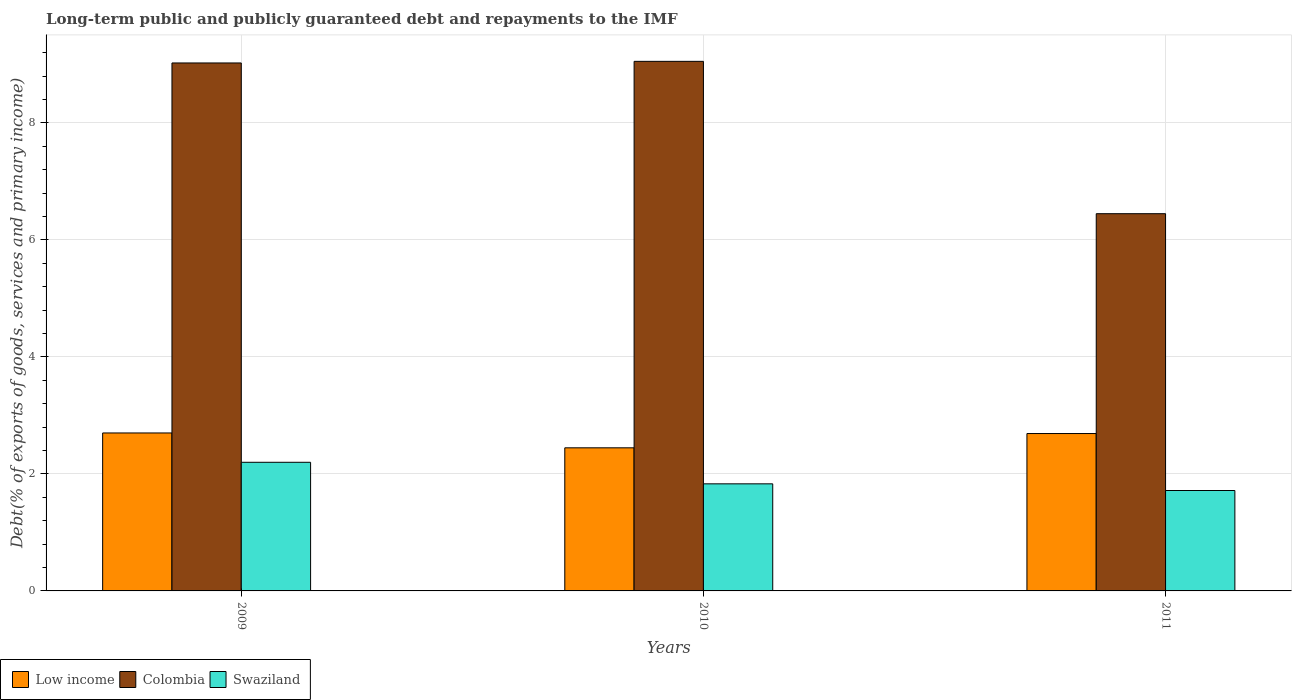How many different coloured bars are there?
Keep it short and to the point. 3. Are the number of bars per tick equal to the number of legend labels?
Keep it short and to the point. Yes. How many bars are there on the 2nd tick from the right?
Provide a succinct answer. 3. What is the debt and repayments in Low income in 2010?
Offer a very short reply. 2.45. Across all years, what is the maximum debt and repayments in Swaziland?
Your response must be concise. 2.2. Across all years, what is the minimum debt and repayments in Low income?
Ensure brevity in your answer.  2.45. In which year was the debt and repayments in Low income maximum?
Provide a short and direct response. 2009. In which year was the debt and repayments in Colombia minimum?
Provide a succinct answer. 2011. What is the total debt and repayments in Low income in the graph?
Keep it short and to the point. 7.84. What is the difference between the debt and repayments in Swaziland in 2009 and that in 2010?
Give a very brief answer. 0.37. What is the difference between the debt and repayments in Low income in 2010 and the debt and repayments in Swaziland in 2009?
Make the answer very short. 0.25. What is the average debt and repayments in Low income per year?
Make the answer very short. 2.61. In the year 2011, what is the difference between the debt and repayments in Swaziland and debt and repayments in Low income?
Your answer should be compact. -0.97. In how many years, is the debt and repayments in Swaziland greater than 3.6 %?
Provide a succinct answer. 0. What is the ratio of the debt and repayments in Swaziland in 2010 to that in 2011?
Your answer should be compact. 1.07. Is the debt and repayments in Colombia in 2010 less than that in 2011?
Your answer should be compact. No. Is the difference between the debt and repayments in Swaziland in 2009 and 2010 greater than the difference between the debt and repayments in Low income in 2009 and 2010?
Your answer should be very brief. Yes. What is the difference between the highest and the second highest debt and repayments in Swaziland?
Offer a very short reply. 0.37. What is the difference between the highest and the lowest debt and repayments in Colombia?
Your response must be concise. 2.6. In how many years, is the debt and repayments in Swaziland greater than the average debt and repayments in Swaziland taken over all years?
Your answer should be compact. 1. What does the 3rd bar from the left in 2009 represents?
Your answer should be very brief. Swaziland. What does the 1st bar from the right in 2011 represents?
Ensure brevity in your answer.  Swaziland. How many bars are there?
Ensure brevity in your answer.  9. Are all the bars in the graph horizontal?
Your answer should be compact. No. Does the graph contain any zero values?
Give a very brief answer. No. Where does the legend appear in the graph?
Make the answer very short. Bottom left. How many legend labels are there?
Provide a succinct answer. 3. How are the legend labels stacked?
Provide a short and direct response. Horizontal. What is the title of the graph?
Offer a terse response. Long-term public and publicly guaranteed debt and repayments to the IMF. What is the label or title of the X-axis?
Give a very brief answer. Years. What is the label or title of the Y-axis?
Give a very brief answer. Debt(% of exports of goods, services and primary income). What is the Debt(% of exports of goods, services and primary income) of Low income in 2009?
Provide a succinct answer. 2.7. What is the Debt(% of exports of goods, services and primary income) of Colombia in 2009?
Your answer should be very brief. 9.02. What is the Debt(% of exports of goods, services and primary income) of Swaziland in 2009?
Your answer should be compact. 2.2. What is the Debt(% of exports of goods, services and primary income) of Low income in 2010?
Your response must be concise. 2.45. What is the Debt(% of exports of goods, services and primary income) of Colombia in 2010?
Provide a short and direct response. 9.05. What is the Debt(% of exports of goods, services and primary income) in Swaziland in 2010?
Ensure brevity in your answer.  1.83. What is the Debt(% of exports of goods, services and primary income) of Low income in 2011?
Provide a succinct answer. 2.69. What is the Debt(% of exports of goods, services and primary income) of Colombia in 2011?
Your response must be concise. 6.45. What is the Debt(% of exports of goods, services and primary income) in Swaziland in 2011?
Offer a terse response. 1.72. Across all years, what is the maximum Debt(% of exports of goods, services and primary income) in Low income?
Give a very brief answer. 2.7. Across all years, what is the maximum Debt(% of exports of goods, services and primary income) of Colombia?
Provide a short and direct response. 9.05. Across all years, what is the maximum Debt(% of exports of goods, services and primary income) in Swaziland?
Offer a very short reply. 2.2. Across all years, what is the minimum Debt(% of exports of goods, services and primary income) in Low income?
Provide a short and direct response. 2.45. Across all years, what is the minimum Debt(% of exports of goods, services and primary income) of Colombia?
Offer a very short reply. 6.45. Across all years, what is the minimum Debt(% of exports of goods, services and primary income) in Swaziland?
Your answer should be very brief. 1.72. What is the total Debt(% of exports of goods, services and primary income) in Low income in the graph?
Provide a succinct answer. 7.84. What is the total Debt(% of exports of goods, services and primary income) of Colombia in the graph?
Ensure brevity in your answer.  24.53. What is the total Debt(% of exports of goods, services and primary income) in Swaziland in the graph?
Keep it short and to the point. 5.75. What is the difference between the Debt(% of exports of goods, services and primary income) in Low income in 2009 and that in 2010?
Your answer should be compact. 0.25. What is the difference between the Debt(% of exports of goods, services and primary income) in Colombia in 2009 and that in 2010?
Ensure brevity in your answer.  -0.03. What is the difference between the Debt(% of exports of goods, services and primary income) of Swaziland in 2009 and that in 2010?
Offer a very short reply. 0.37. What is the difference between the Debt(% of exports of goods, services and primary income) in Low income in 2009 and that in 2011?
Provide a short and direct response. 0.01. What is the difference between the Debt(% of exports of goods, services and primary income) in Colombia in 2009 and that in 2011?
Provide a short and direct response. 2.58. What is the difference between the Debt(% of exports of goods, services and primary income) in Swaziland in 2009 and that in 2011?
Keep it short and to the point. 0.48. What is the difference between the Debt(% of exports of goods, services and primary income) of Low income in 2010 and that in 2011?
Give a very brief answer. -0.24. What is the difference between the Debt(% of exports of goods, services and primary income) in Colombia in 2010 and that in 2011?
Your answer should be compact. 2.6. What is the difference between the Debt(% of exports of goods, services and primary income) in Swaziland in 2010 and that in 2011?
Make the answer very short. 0.11. What is the difference between the Debt(% of exports of goods, services and primary income) of Low income in 2009 and the Debt(% of exports of goods, services and primary income) of Colombia in 2010?
Make the answer very short. -6.35. What is the difference between the Debt(% of exports of goods, services and primary income) in Low income in 2009 and the Debt(% of exports of goods, services and primary income) in Swaziland in 2010?
Provide a succinct answer. 0.87. What is the difference between the Debt(% of exports of goods, services and primary income) in Colombia in 2009 and the Debt(% of exports of goods, services and primary income) in Swaziland in 2010?
Provide a short and direct response. 7.19. What is the difference between the Debt(% of exports of goods, services and primary income) of Low income in 2009 and the Debt(% of exports of goods, services and primary income) of Colombia in 2011?
Give a very brief answer. -3.75. What is the difference between the Debt(% of exports of goods, services and primary income) in Low income in 2009 and the Debt(% of exports of goods, services and primary income) in Swaziland in 2011?
Give a very brief answer. 0.98. What is the difference between the Debt(% of exports of goods, services and primary income) in Colombia in 2009 and the Debt(% of exports of goods, services and primary income) in Swaziland in 2011?
Offer a terse response. 7.31. What is the difference between the Debt(% of exports of goods, services and primary income) of Low income in 2010 and the Debt(% of exports of goods, services and primary income) of Colombia in 2011?
Your response must be concise. -4. What is the difference between the Debt(% of exports of goods, services and primary income) in Low income in 2010 and the Debt(% of exports of goods, services and primary income) in Swaziland in 2011?
Ensure brevity in your answer.  0.73. What is the difference between the Debt(% of exports of goods, services and primary income) in Colombia in 2010 and the Debt(% of exports of goods, services and primary income) in Swaziland in 2011?
Your response must be concise. 7.34. What is the average Debt(% of exports of goods, services and primary income) in Low income per year?
Keep it short and to the point. 2.61. What is the average Debt(% of exports of goods, services and primary income) in Colombia per year?
Keep it short and to the point. 8.18. What is the average Debt(% of exports of goods, services and primary income) in Swaziland per year?
Your answer should be compact. 1.92. In the year 2009, what is the difference between the Debt(% of exports of goods, services and primary income) in Low income and Debt(% of exports of goods, services and primary income) in Colombia?
Your answer should be very brief. -6.32. In the year 2009, what is the difference between the Debt(% of exports of goods, services and primary income) of Low income and Debt(% of exports of goods, services and primary income) of Swaziland?
Keep it short and to the point. 0.5. In the year 2009, what is the difference between the Debt(% of exports of goods, services and primary income) of Colombia and Debt(% of exports of goods, services and primary income) of Swaziland?
Your answer should be compact. 6.83. In the year 2010, what is the difference between the Debt(% of exports of goods, services and primary income) of Low income and Debt(% of exports of goods, services and primary income) of Colombia?
Your answer should be compact. -6.61. In the year 2010, what is the difference between the Debt(% of exports of goods, services and primary income) in Low income and Debt(% of exports of goods, services and primary income) in Swaziland?
Provide a succinct answer. 0.62. In the year 2010, what is the difference between the Debt(% of exports of goods, services and primary income) of Colombia and Debt(% of exports of goods, services and primary income) of Swaziland?
Offer a terse response. 7.22. In the year 2011, what is the difference between the Debt(% of exports of goods, services and primary income) in Low income and Debt(% of exports of goods, services and primary income) in Colombia?
Your response must be concise. -3.76. In the year 2011, what is the difference between the Debt(% of exports of goods, services and primary income) of Low income and Debt(% of exports of goods, services and primary income) of Swaziland?
Make the answer very short. 0.97. In the year 2011, what is the difference between the Debt(% of exports of goods, services and primary income) of Colombia and Debt(% of exports of goods, services and primary income) of Swaziland?
Provide a short and direct response. 4.73. What is the ratio of the Debt(% of exports of goods, services and primary income) of Low income in 2009 to that in 2010?
Give a very brief answer. 1.1. What is the ratio of the Debt(% of exports of goods, services and primary income) in Swaziland in 2009 to that in 2010?
Give a very brief answer. 1.2. What is the ratio of the Debt(% of exports of goods, services and primary income) of Colombia in 2009 to that in 2011?
Your answer should be compact. 1.4. What is the ratio of the Debt(% of exports of goods, services and primary income) in Swaziland in 2009 to that in 2011?
Offer a very short reply. 1.28. What is the ratio of the Debt(% of exports of goods, services and primary income) of Low income in 2010 to that in 2011?
Make the answer very short. 0.91. What is the ratio of the Debt(% of exports of goods, services and primary income) of Colombia in 2010 to that in 2011?
Offer a very short reply. 1.4. What is the ratio of the Debt(% of exports of goods, services and primary income) of Swaziland in 2010 to that in 2011?
Your answer should be compact. 1.07. What is the difference between the highest and the second highest Debt(% of exports of goods, services and primary income) in Low income?
Provide a succinct answer. 0.01. What is the difference between the highest and the second highest Debt(% of exports of goods, services and primary income) of Colombia?
Make the answer very short. 0.03. What is the difference between the highest and the second highest Debt(% of exports of goods, services and primary income) of Swaziland?
Provide a short and direct response. 0.37. What is the difference between the highest and the lowest Debt(% of exports of goods, services and primary income) in Low income?
Offer a very short reply. 0.25. What is the difference between the highest and the lowest Debt(% of exports of goods, services and primary income) of Colombia?
Offer a terse response. 2.6. What is the difference between the highest and the lowest Debt(% of exports of goods, services and primary income) in Swaziland?
Give a very brief answer. 0.48. 